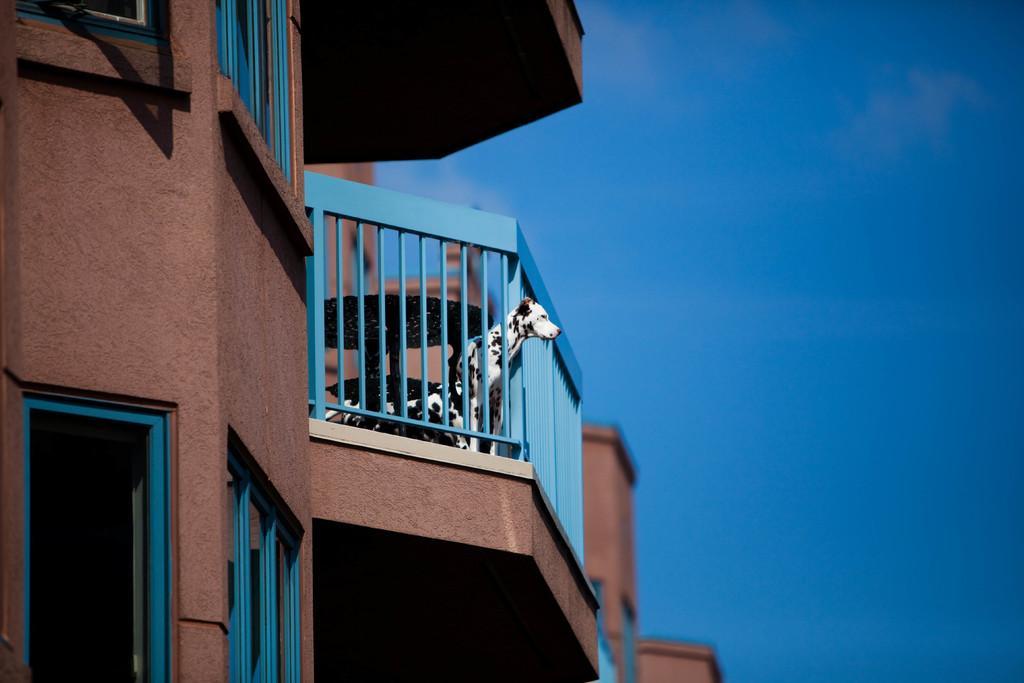How would you summarize this image in a sentence or two? In this picture we can see a dog standing at fence, buildings with windows and in the background we can see the sky. 